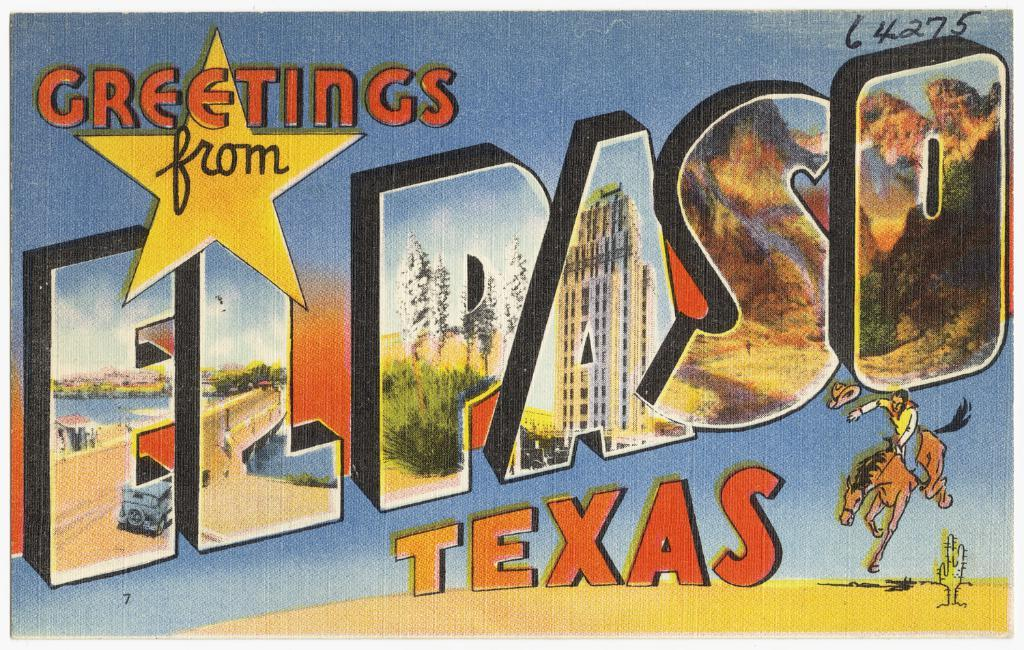<image>
Describe the image concisely. A postcard relays Greetings From El Paso Texas. 